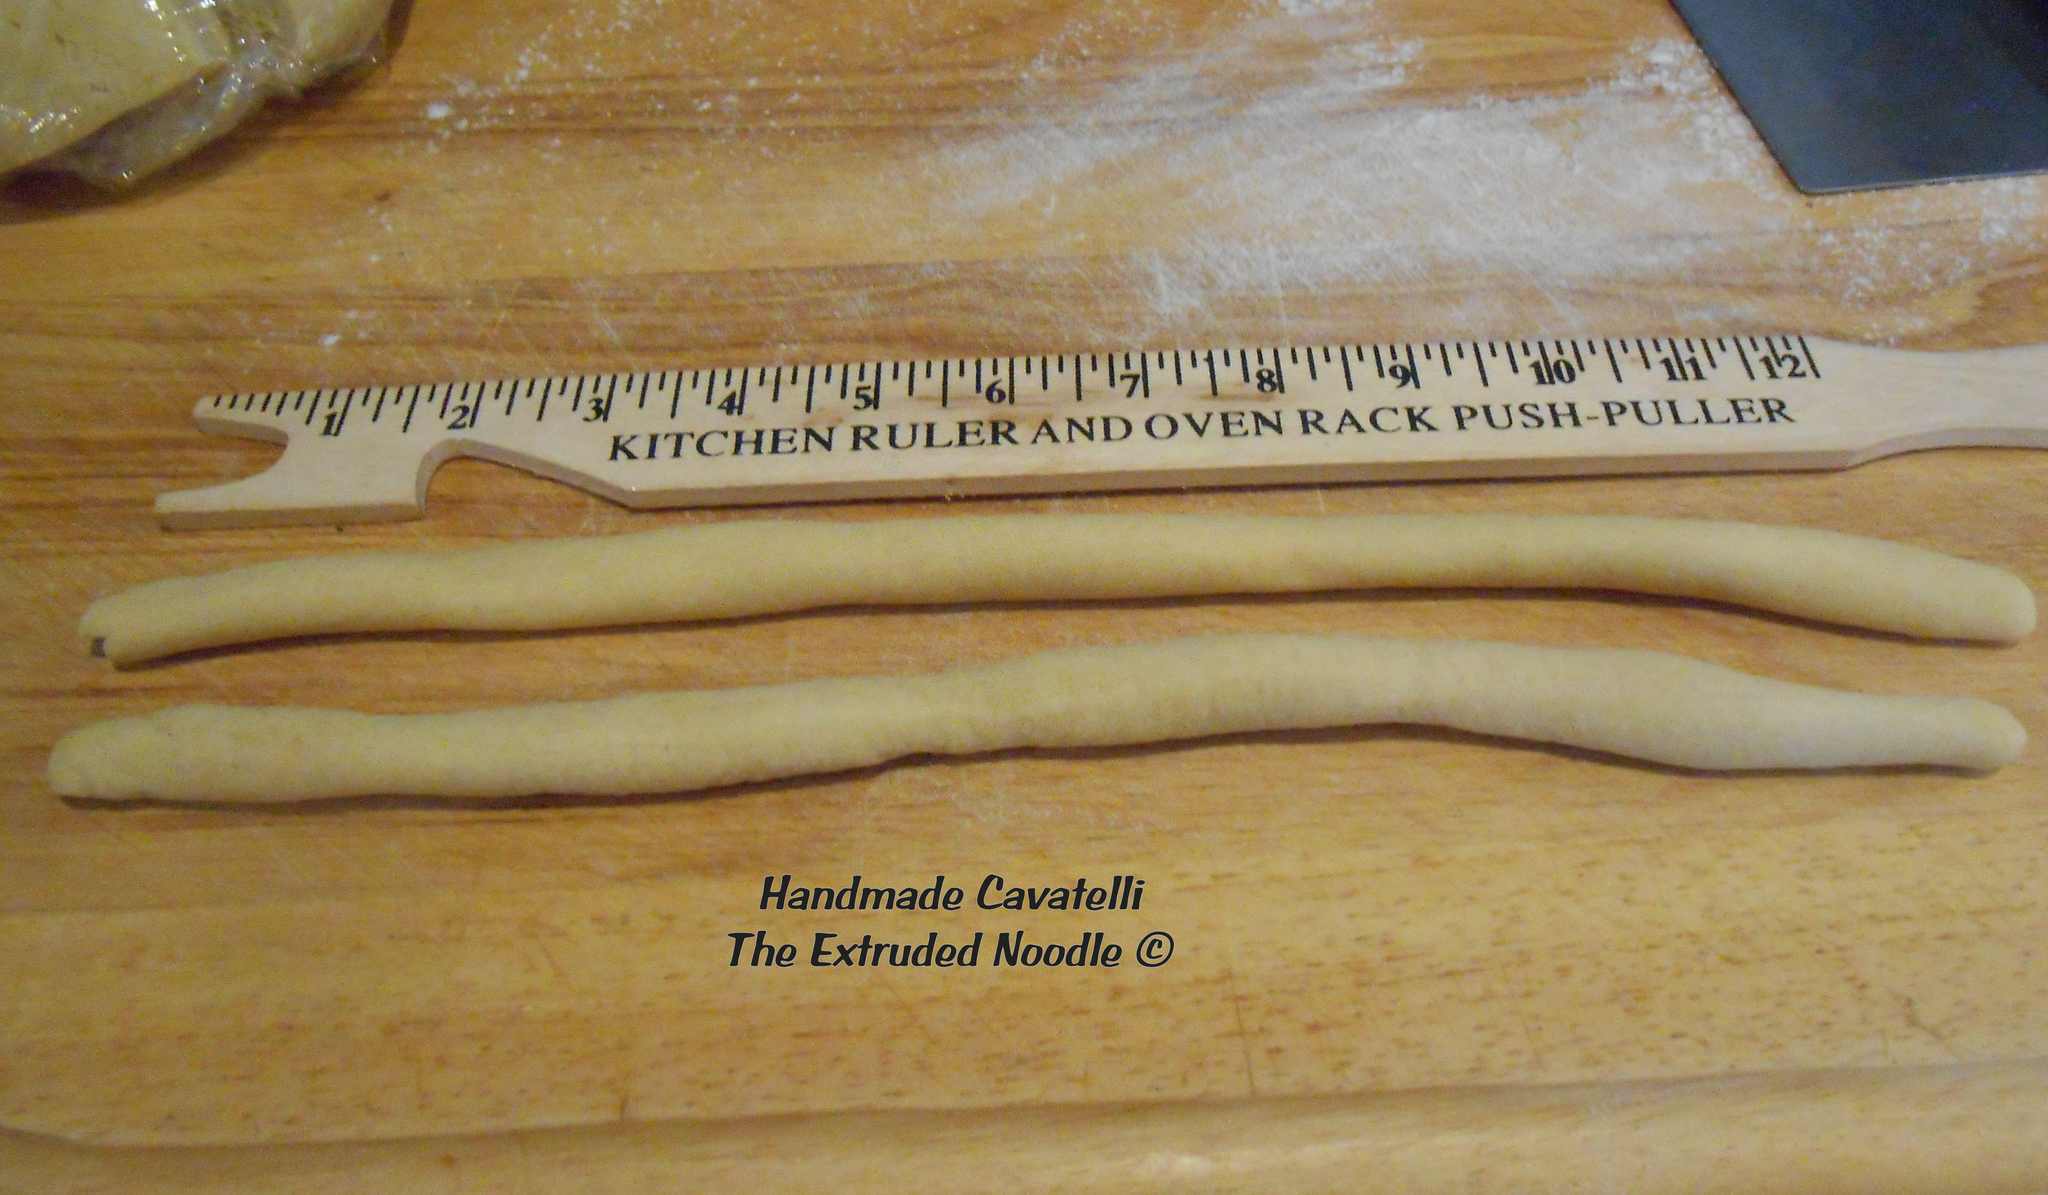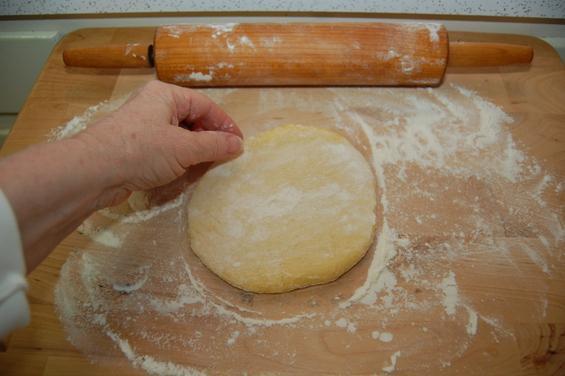The first image is the image on the left, the second image is the image on the right. Analyze the images presented: Is the assertion "The left image shows dough in a roundish shape on a floured board, and the right image shows dough that has been flattened." valid? Answer yes or no. No. The first image is the image on the left, the second image is the image on the right. For the images displayed, is the sentence "A rolling pin is on a wooden cutting board." factually correct? Answer yes or no. Yes. 